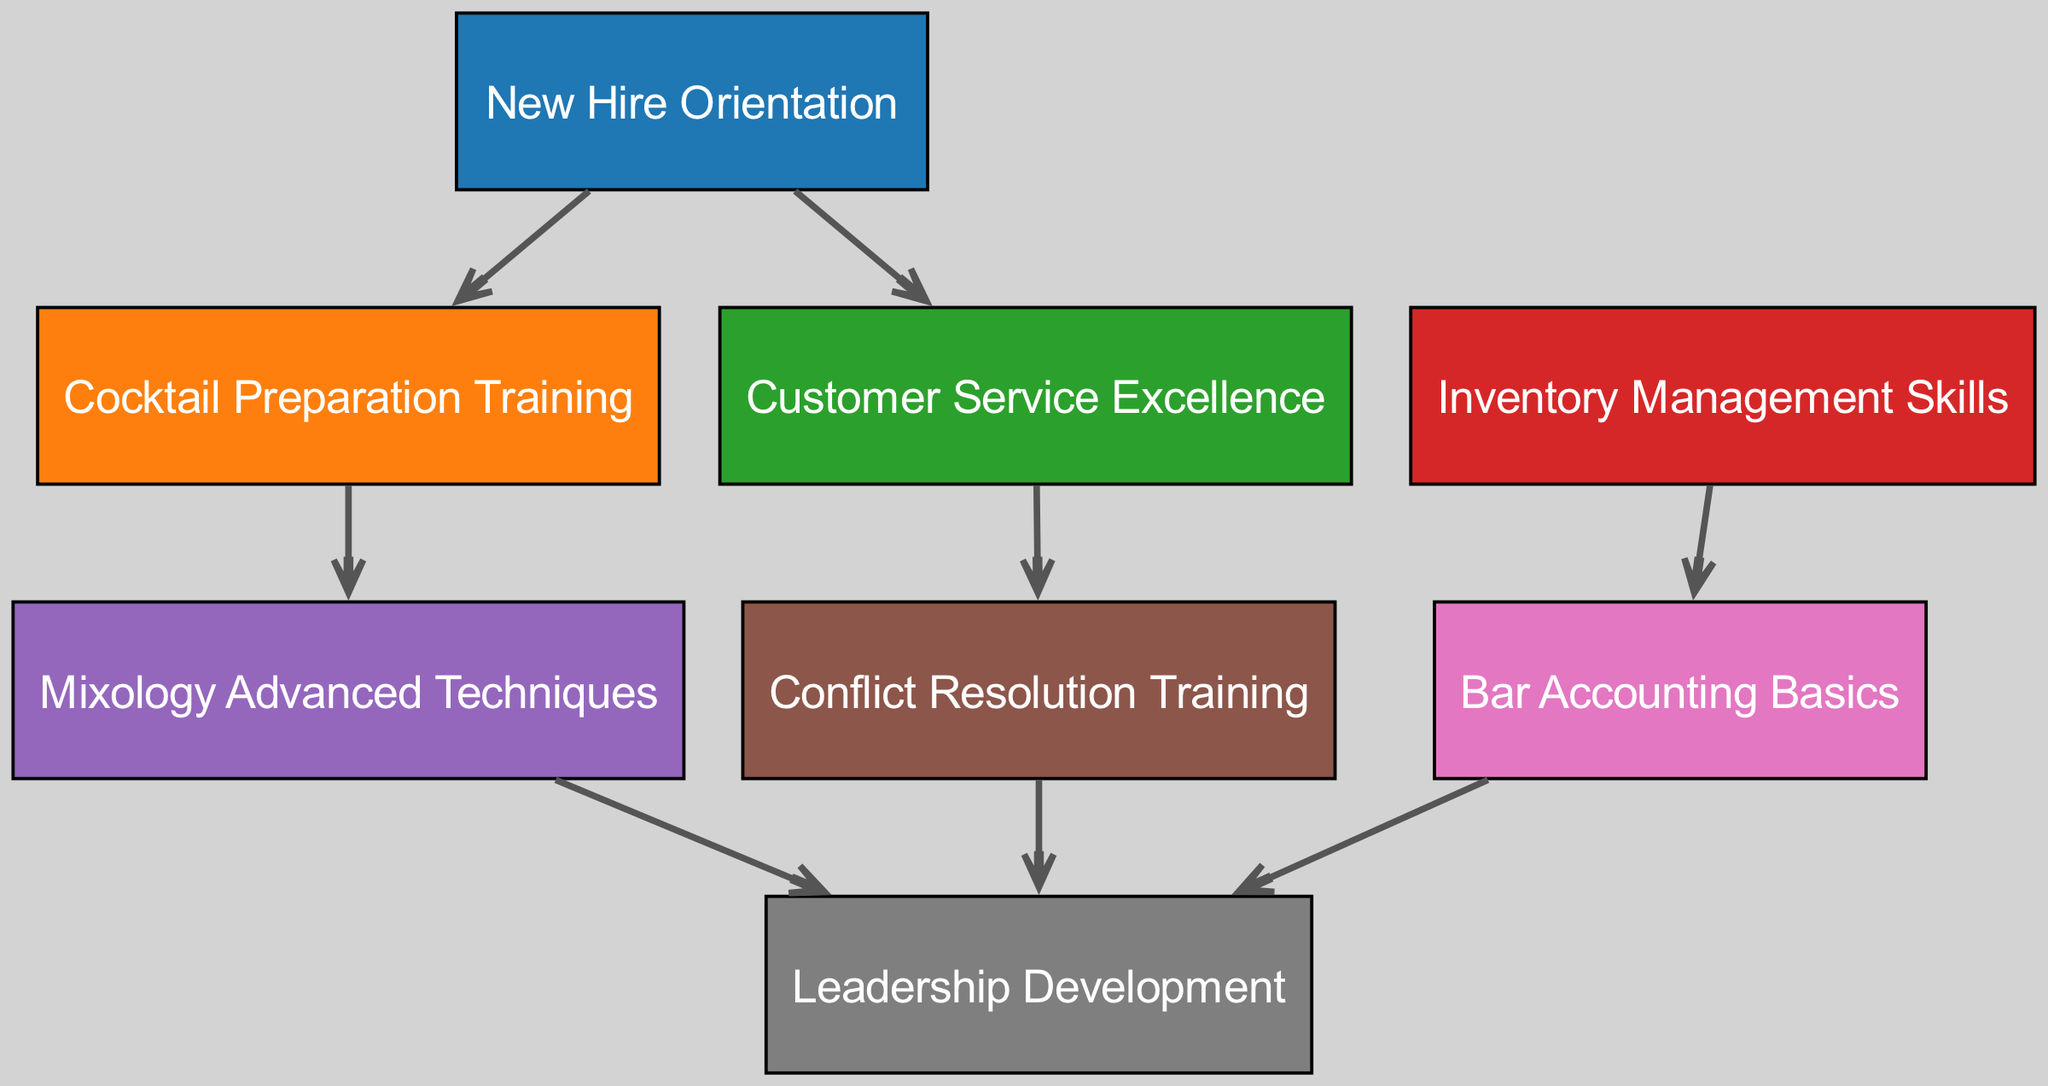What is the first training node in the progression? The first training node is "New Hire Orientation," as it is represented as the starting point in the directed graph.
Answer: New Hire Orientation How many nodes are there in the diagram? By counting each listed training component in the nodes section, we find there are eight distinct nodes.
Answer: Eight What is the last training node in the skill development path? The last training node is "Leadership Development," which is the endpoint for multiple paths in the graph, indicating it is the final stage.
Answer: Leadership Development Which training follows "Cocktail Preparation Training"? The edge pointing from "Cocktail Preparation Training" leads to "Mixology Advanced Techniques," indicating that it is the subsequent training step.
Answer: Mixology Advanced Techniques What is the relationship between "Customer Service Excellence" and "Conflict Resolution Training"? From the directed graph, "Customer Service Excellence" leads to "Conflict Resolution Training," showing that they are sequentially connected in the training path.
Answer: Sequentially connected How many paths lead into "Leadership Development"? There are three paths pointing into "Leadership Development," originating from "Mixology Advanced Techniques," "Conflict Resolution Training," and "Bar Accounting Basics."
Answer: Three Which node has the most edges going out from it? "New Hire Orientation" has two outgoing edges, leading to "Cocktail Preparation Training" and "Customer Service Excellence," making it the node with the most outgoing connections.
Answer: New Hire Orientation What is the direct predecessor of "Bar Accounting Basics"? "Inventory Management Skills" directly precedes "Bar Accounting Basics," indicating a clear progression from inventory skills to accounting basics.
Answer: Inventory Management Skills Which two nodes are not connected to any other nodes? None of the nodes remain unconnected; all nodes have at least one incoming or outgoing edge, showing that every training level is part of the progression.
Answer: None 